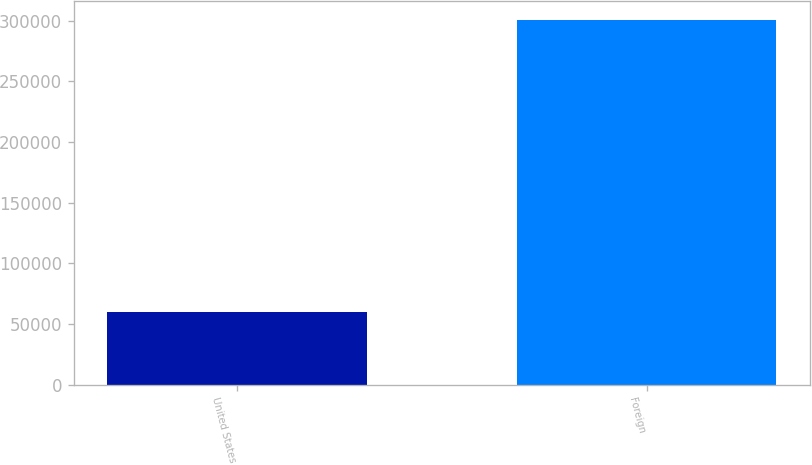Convert chart. <chart><loc_0><loc_0><loc_500><loc_500><bar_chart><fcel>United States<fcel>Foreign<nl><fcel>59876<fcel>301036<nl></chart> 